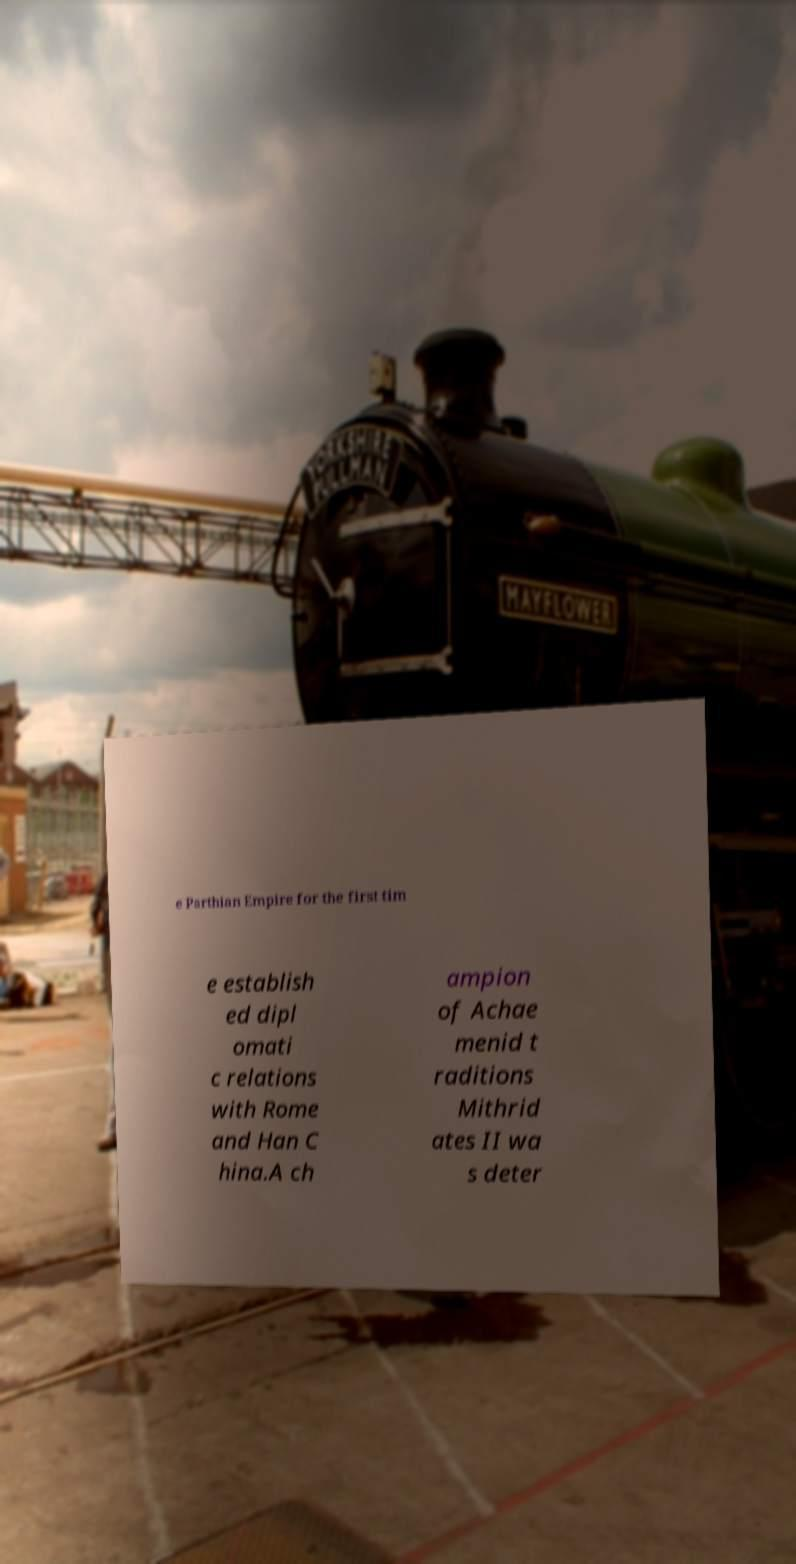Can you read and provide the text displayed in the image?This photo seems to have some interesting text. Can you extract and type it out for me? e Parthian Empire for the first tim e establish ed dipl omati c relations with Rome and Han C hina.A ch ampion of Achae menid t raditions Mithrid ates II wa s deter 